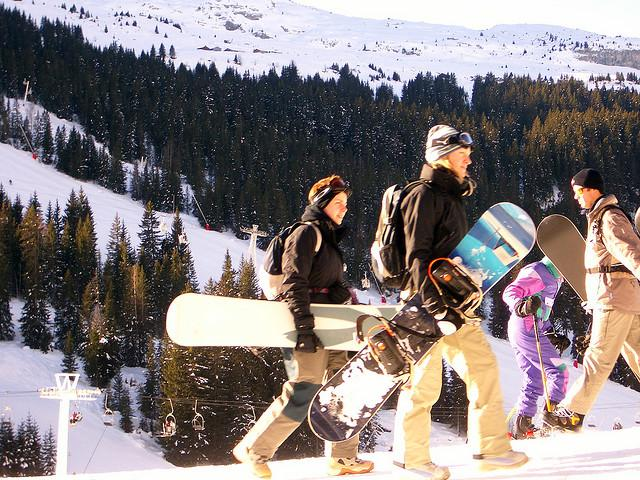What are these people in the front carrying?

Choices:
A) snowboards
B) surfboards
C) skates
D) skateboards snowboards 